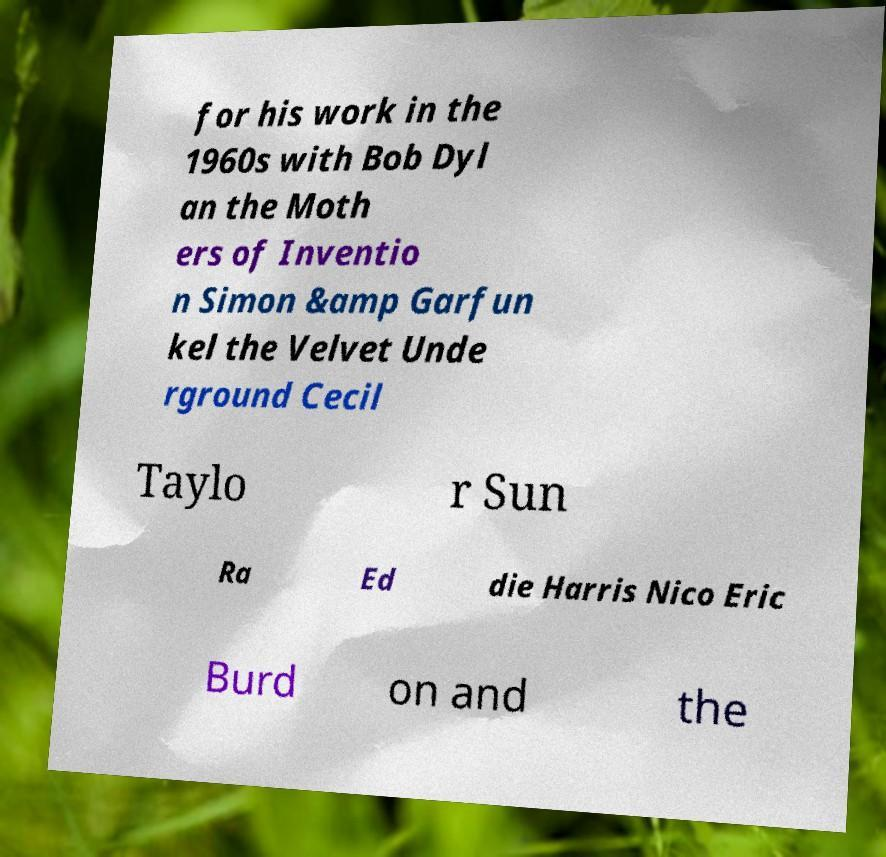Can you accurately transcribe the text from the provided image for me? for his work in the 1960s with Bob Dyl an the Moth ers of Inventio n Simon &amp Garfun kel the Velvet Unde rground Cecil Taylo r Sun Ra Ed die Harris Nico Eric Burd on and the 